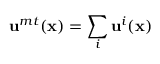Convert formula to latex. <formula><loc_0><loc_0><loc_500><loc_500>u ^ { m t } ( x ) = \sum _ { i } u ^ { i } ( x )</formula> 